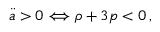<formula> <loc_0><loc_0><loc_500><loc_500>\ddot { a } > 0 \Longleftrightarrow \rho + 3 p < 0 \, ,</formula> 